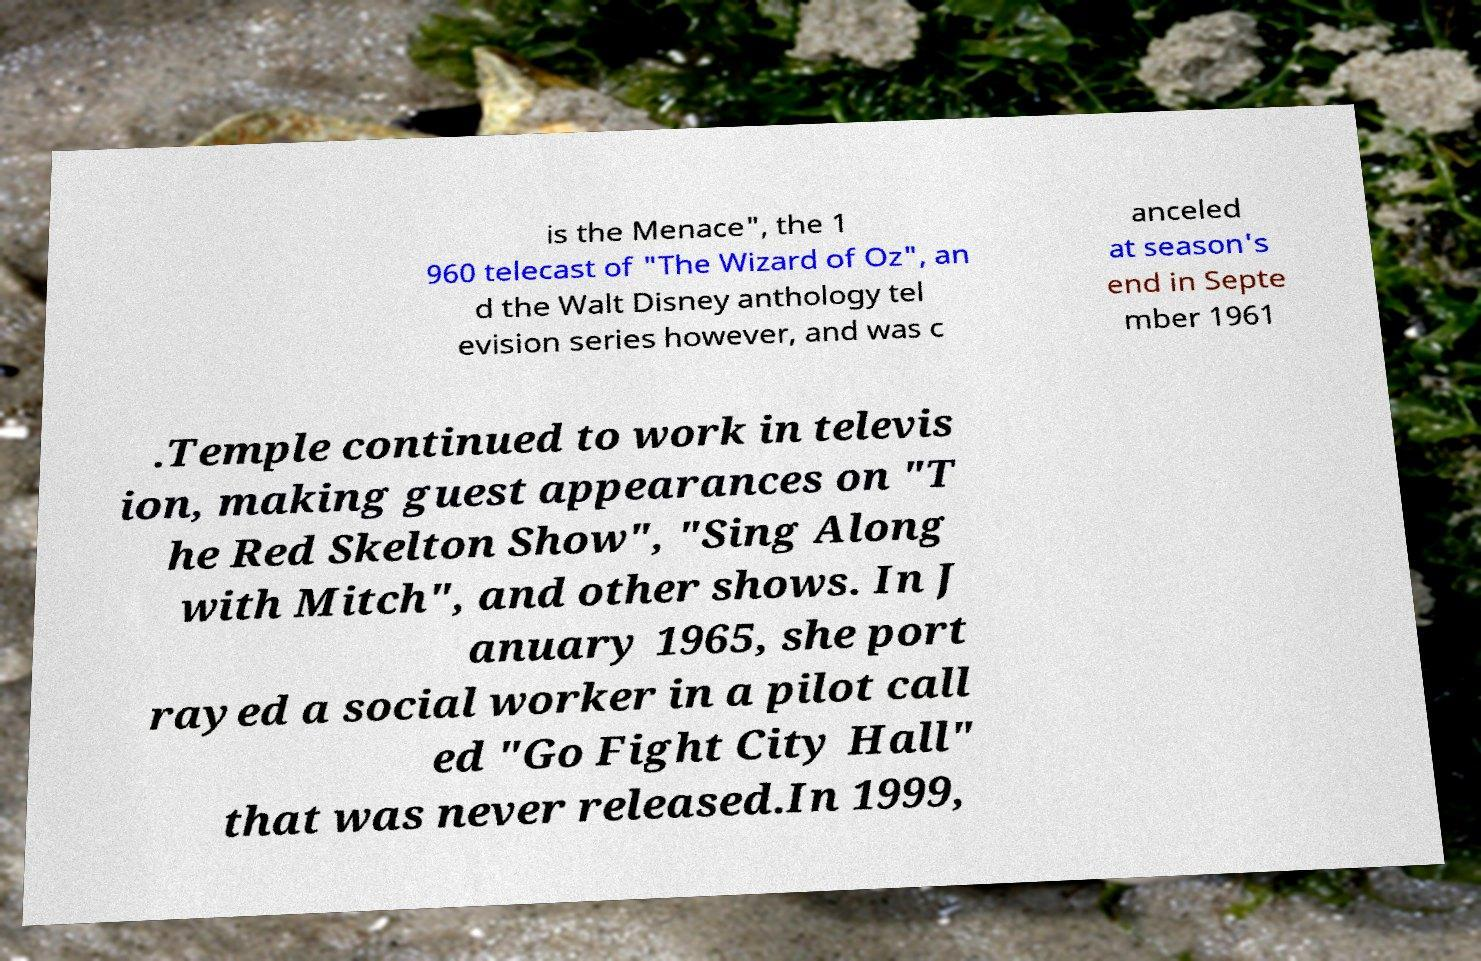Please identify and transcribe the text found in this image. is the Menace", the 1 960 telecast of "The Wizard of Oz", an d the Walt Disney anthology tel evision series however, and was c anceled at season's end in Septe mber 1961 .Temple continued to work in televis ion, making guest appearances on "T he Red Skelton Show", "Sing Along with Mitch", and other shows. In J anuary 1965, she port rayed a social worker in a pilot call ed "Go Fight City Hall" that was never released.In 1999, 